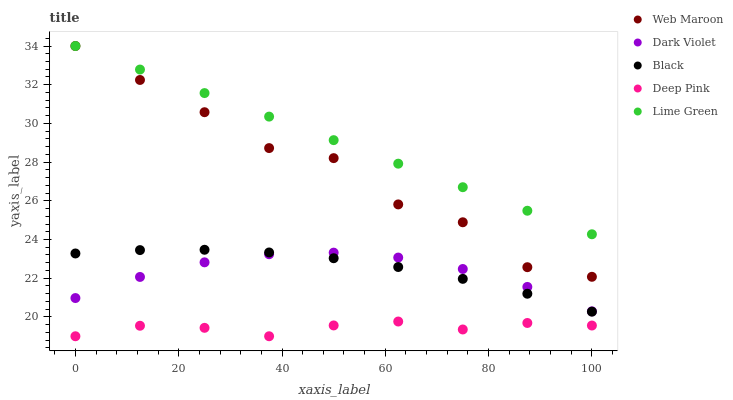Does Deep Pink have the minimum area under the curve?
Answer yes or no. Yes. Does Lime Green have the maximum area under the curve?
Answer yes or no. Yes. Does Black have the minimum area under the curve?
Answer yes or no. No. Does Black have the maximum area under the curve?
Answer yes or no. No. Is Lime Green the smoothest?
Answer yes or no. Yes. Is Web Maroon the roughest?
Answer yes or no. Yes. Is Black the smoothest?
Answer yes or no. No. Is Black the roughest?
Answer yes or no. No. Does Deep Pink have the lowest value?
Answer yes or no. Yes. Does Black have the lowest value?
Answer yes or no. No. Does Web Maroon have the highest value?
Answer yes or no. Yes. Does Black have the highest value?
Answer yes or no. No. Is Dark Violet less than Web Maroon?
Answer yes or no. Yes. Is Lime Green greater than Deep Pink?
Answer yes or no. Yes. Does Lime Green intersect Web Maroon?
Answer yes or no. Yes. Is Lime Green less than Web Maroon?
Answer yes or no. No. Is Lime Green greater than Web Maroon?
Answer yes or no. No. Does Dark Violet intersect Web Maroon?
Answer yes or no. No. 